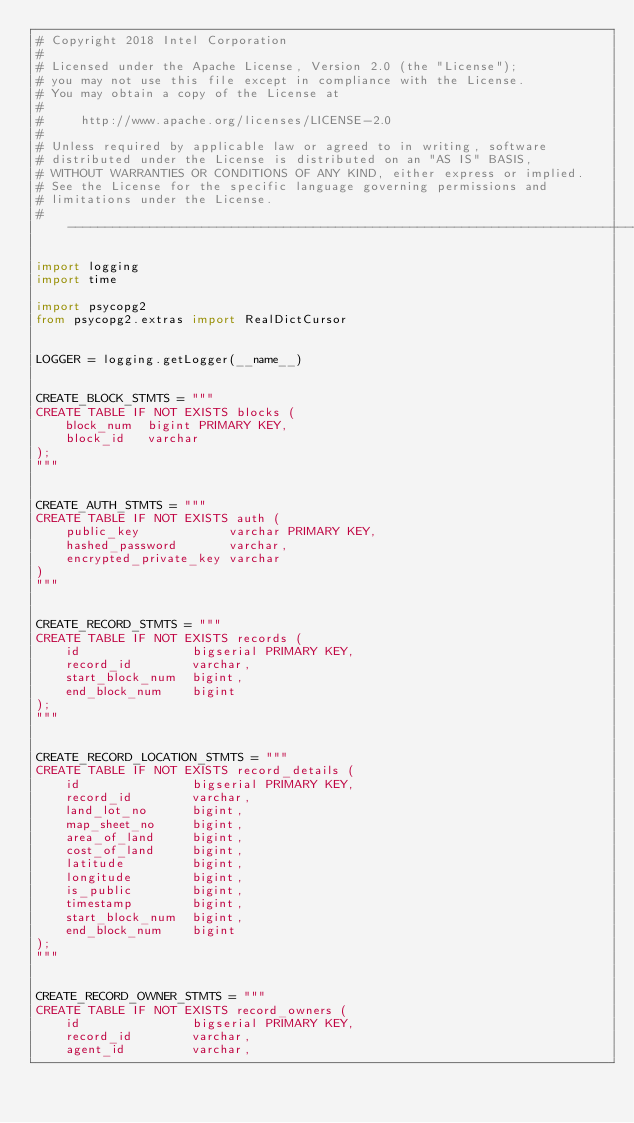<code> <loc_0><loc_0><loc_500><loc_500><_Python_># Copyright 2018 Intel Corporation
#
# Licensed under the Apache License, Version 2.0 (the "License");
# you may not use this file except in compliance with the License.
# You may obtain a copy of the License at
#
#     http://www.apache.org/licenses/LICENSE-2.0
#
# Unless required by applicable law or agreed to in writing, software
# distributed under the License is distributed on an "AS IS" BASIS,
# WITHOUT WARRANTIES OR CONDITIONS OF ANY KIND, either express or implied.
# See the License for the specific language governing permissions and
# limitations under the License.
# -----------------------------------------------------------------------------

import logging
import time

import psycopg2
from psycopg2.extras import RealDictCursor


LOGGER = logging.getLogger(__name__)


CREATE_BLOCK_STMTS = """
CREATE TABLE IF NOT EXISTS blocks (
    block_num  bigint PRIMARY KEY,
    block_id   varchar
);
"""


CREATE_AUTH_STMTS = """
CREATE TABLE IF NOT EXISTS auth (
    public_key            varchar PRIMARY KEY,
    hashed_password       varchar,
    encrypted_private_key varchar
)
"""


CREATE_RECORD_STMTS = """
CREATE TABLE IF NOT EXISTS records (
    id               bigserial PRIMARY KEY,
    record_id        varchar,
    start_block_num  bigint,
    end_block_num    bigint
);
"""


CREATE_RECORD_LOCATION_STMTS = """
CREATE TABLE IF NOT EXISTS record_details (
    id               bigserial PRIMARY KEY,
    record_id        varchar,
    land_lot_no      bigint,
    map_sheet_no     bigint,
    area_of_land     bigint,  
    cost_of_land     bigint,
    latitude         bigint,
    longitude        bigint,
    is_public        bigint,   
    timestamp        bigint,
    start_block_num  bigint,
    end_block_num    bigint
);
"""


CREATE_RECORD_OWNER_STMTS = """
CREATE TABLE IF NOT EXISTS record_owners (
    id               bigserial PRIMARY KEY,
    record_id        varchar,
    agent_id         varchar,</code> 